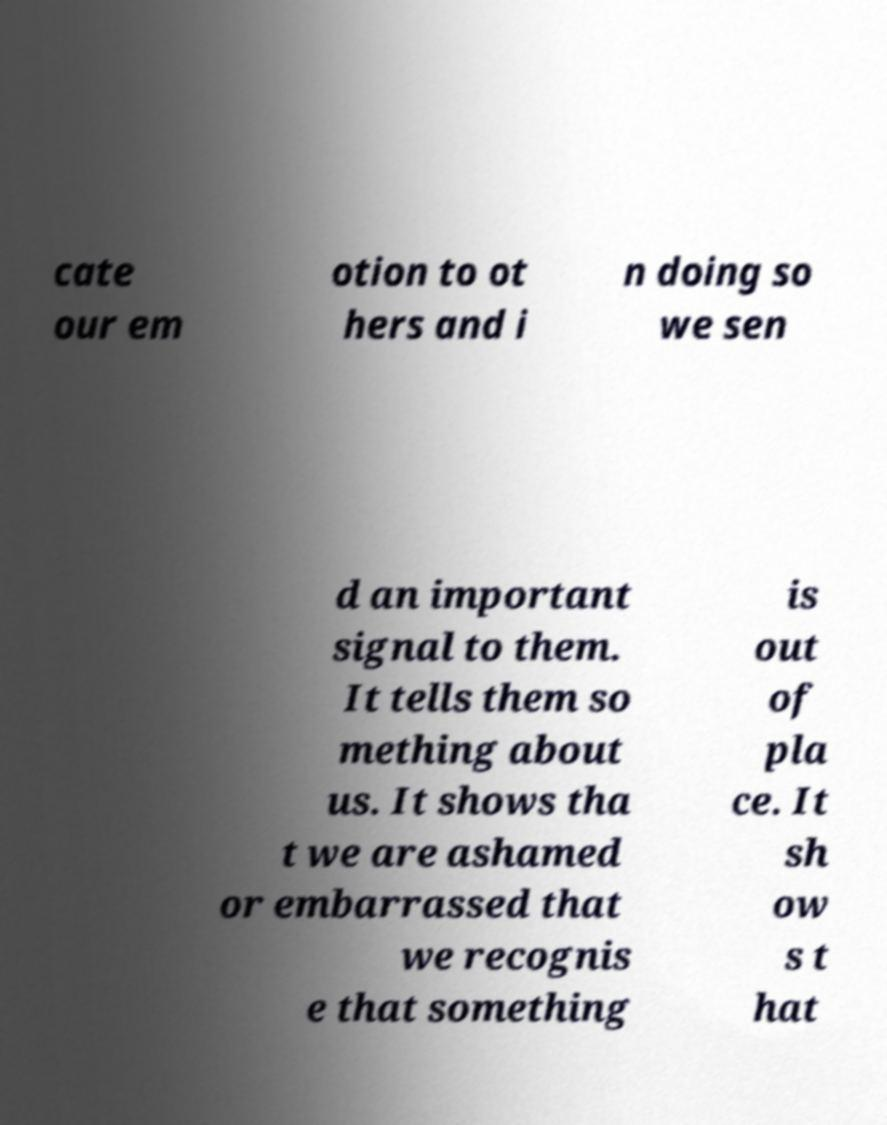I need the written content from this picture converted into text. Can you do that? cate our em otion to ot hers and i n doing so we sen d an important signal to them. It tells them so mething about us. It shows tha t we are ashamed or embarrassed that we recognis e that something is out of pla ce. It sh ow s t hat 